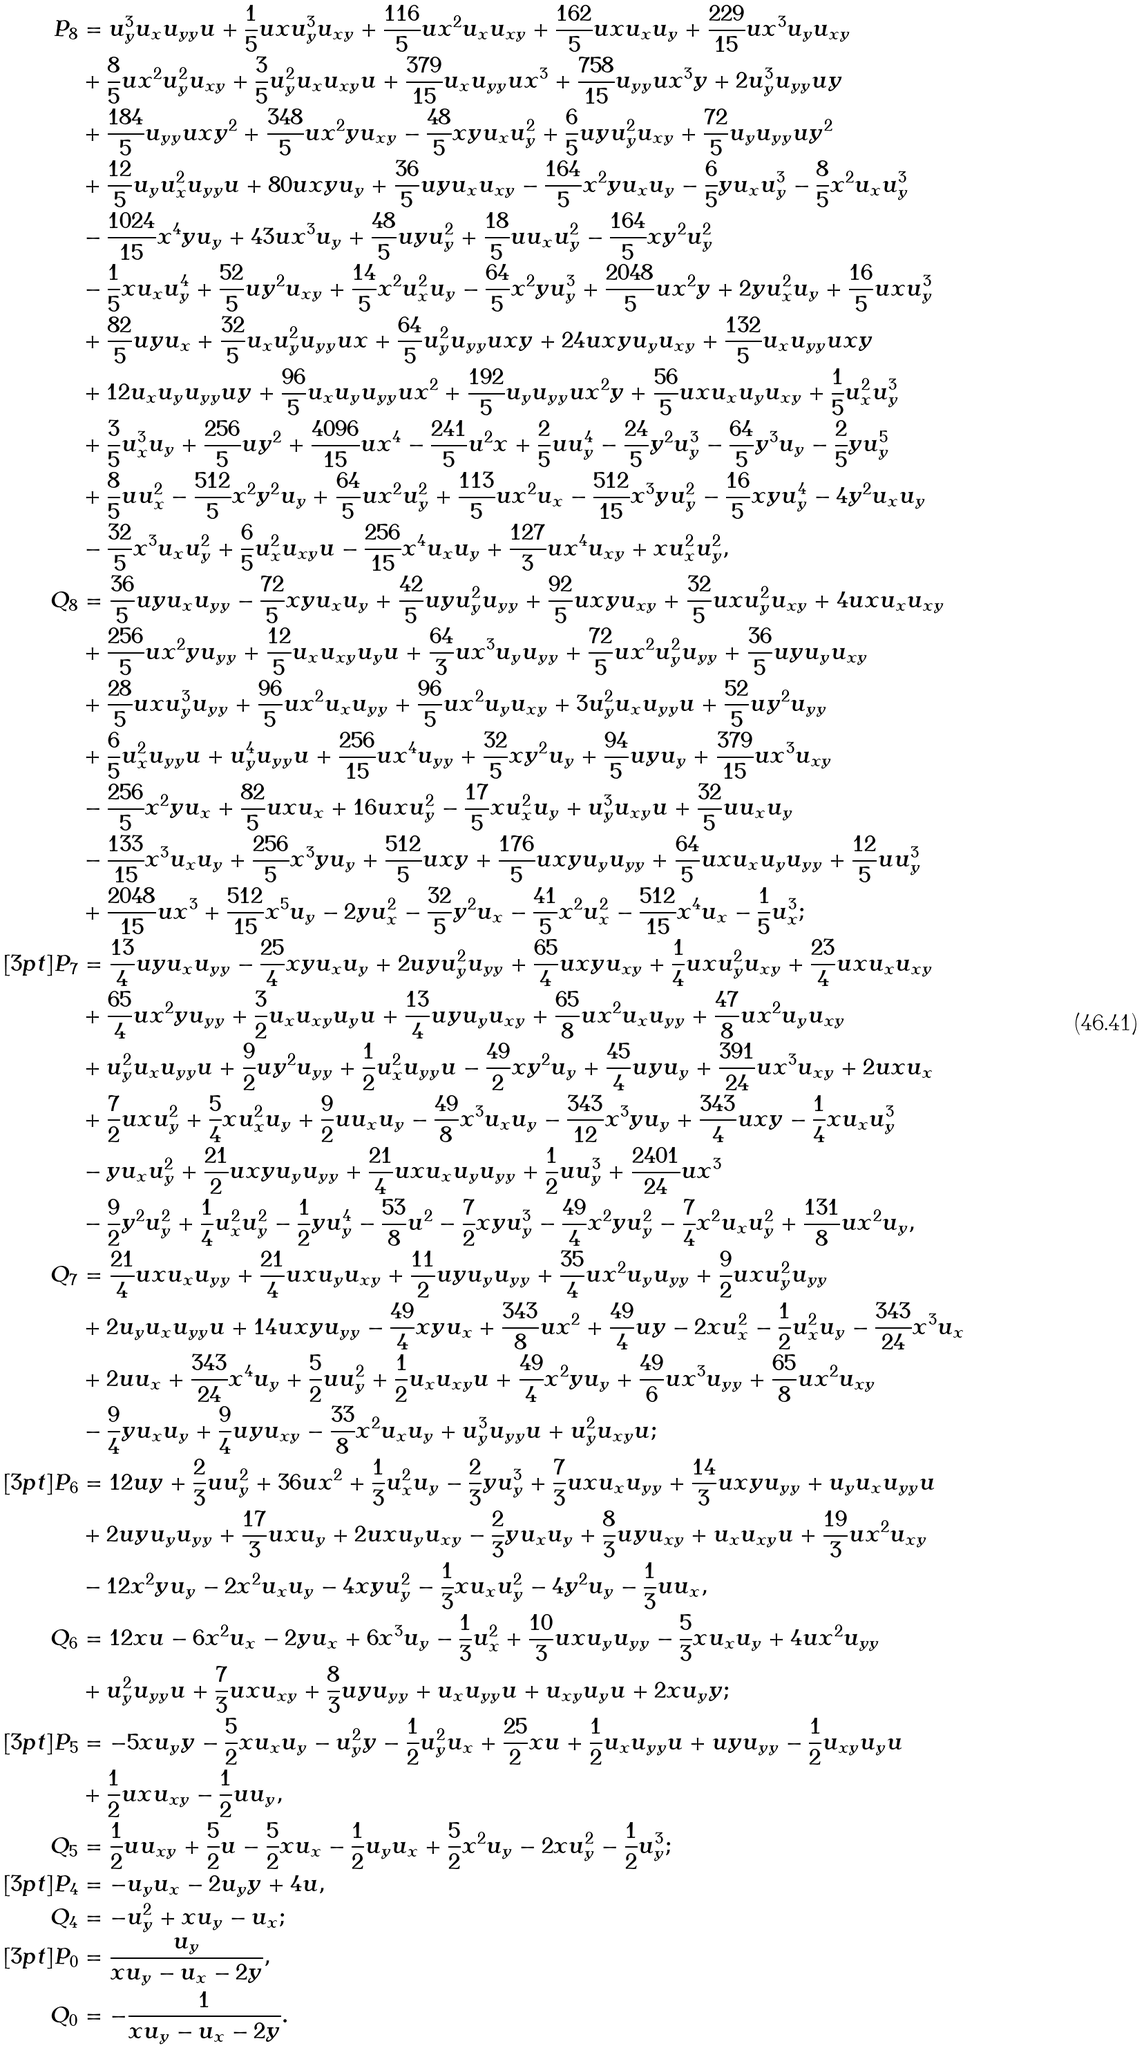<formula> <loc_0><loc_0><loc_500><loc_500>P _ { 8 } & = u _ { y } ^ { 3 } u _ { x } u _ { y y } u + \frac { 1 } { 5 } u x u _ { y } ^ { 3 } u _ { x y } + \frac { 1 1 6 } { 5 } u x ^ { 2 } u _ { x } u _ { x y } + \frac { 1 6 2 } { 5 } u x u _ { x } u _ { y } + \frac { 2 2 9 } { 1 5 } u x ^ { 3 } u _ { y } u _ { x y } \\ & + \frac { 8 } { 5 } u x ^ { 2 } u _ { y } ^ { 2 } u _ { x y } + \frac { 3 } { 5 } u _ { y } ^ { 2 } u _ { x } u _ { x y } u + \frac { 3 7 9 } { 1 5 } u _ { x } u _ { y y } u x ^ { 3 } + \frac { 7 5 8 } { 1 5 } u _ { y y } u x ^ { 3 } y + 2 u _ { y } ^ { 3 } u _ { y y } u y \\ & + \frac { 1 8 4 } { 5 } u _ { y y } u x y ^ { 2 } + \frac { 3 4 8 } { 5 } u x ^ { 2 } y u _ { x y } - \frac { 4 8 } { 5 } x y u _ { x } u _ { y } ^ { 2 } + \frac { 6 } { 5 } u y u _ { y } ^ { 2 } u _ { x y } + \frac { 7 2 } { 5 } u _ { y } u _ { y y } u y ^ { 2 } \\ & + \frac { 1 2 } { 5 } u _ { y } u _ { x } ^ { 2 } u _ { y y } u + 8 0 u x y u _ { y } + \frac { 3 6 } { 5 } u y u _ { x } u _ { x y } - \frac { 1 6 4 } { 5 } x ^ { 2 } y u _ { x } u _ { y } - \frac { 6 } { 5 } y u _ { x } u _ { y } ^ { 3 } - \frac { 8 } { 5 } x ^ { 2 } u _ { x } u _ { y } ^ { 3 } \\ & - \frac { 1 0 2 4 } { 1 5 } x ^ { 4 } y u _ { y } + 4 3 u x ^ { 3 } u _ { y } + \frac { 4 8 } { 5 } u y u _ { y } ^ { 2 } + \frac { 1 8 } { 5 } u u _ { x } u _ { y } ^ { 2 } - \frac { 1 6 4 } { 5 } x y ^ { 2 } u _ { y } ^ { 2 } \\ & - \frac { 1 } { 5 } x u _ { x } u _ { y } ^ { 4 } + \frac { 5 2 } { 5 } u y ^ { 2 } u _ { x y } + \frac { 1 4 } { 5 } x ^ { 2 } u _ { x } ^ { 2 } u _ { y } - \frac { 6 4 } { 5 } x ^ { 2 } y u _ { y } ^ { 3 } + \frac { 2 0 4 8 } { 5 } u x ^ { 2 } y + 2 y u _ { x } ^ { 2 } u _ { y } + \frac { 1 6 } { 5 } u x u _ { y } ^ { 3 } \\ & + \frac { 8 2 } { 5 } u y u _ { x } + \frac { 3 2 } { 5 } u _ { x } u _ { y } ^ { 2 } u _ { y y } u x + \frac { 6 4 } { 5 } u _ { y } ^ { 2 } u _ { y y } u x y + 2 4 u x y u _ { y } u _ { x y } + \frac { 1 3 2 } { 5 } u _ { x } u _ { y y } u x y \\ & + 1 2 u _ { x } u _ { y } u _ { y y } u y + \frac { 9 6 } { 5 } u _ { x } u _ { y } u _ { y y } u x ^ { 2 } + \frac { 1 9 2 } { 5 } u _ { y } u _ { y y } u x ^ { 2 } y + \frac { 5 6 } { 5 } u x u _ { x } u _ { y } u _ { x y } + \frac { 1 } { 5 } u _ { x } ^ { 2 } u _ { y } ^ { 3 } \\ & + \frac { 3 } { 5 } u _ { x } ^ { 3 } u _ { y } + \frac { 2 5 6 } { 5 } u y ^ { 2 } + \frac { 4 0 9 6 } { 1 5 } u x ^ { 4 } - \frac { 2 4 1 } { 5 } u ^ { 2 } x + \frac { 2 } { 5 } u u _ { y } ^ { 4 } - \frac { 2 4 } { 5 } y ^ { 2 } u _ { y } ^ { 3 } - \frac { 6 4 } { 5 } y ^ { 3 } u _ { y } - \frac { 2 } { 5 } y u _ { y } ^ { 5 } \\ & + \frac { 8 } { 5 } u u _ { x } ^ { 2 } - \frac { 5 1 2 } { 5 } x ^ { 2 } y ^ { 2 } u _ { y } + \frac { 6 4 } { 5 } u x ^ { 2 } u _ { y } ^ { 2 } + \frac { 1 1 3 } { 5 } u x ^ { 2 } u _ { x } - \frac { 5 1 2 } { 1 5 } x ^ { 3 } y u _ { y } ^ { 2 } - \frac { 1 6 } { 5 } x y u _ { y } ^ { 4 } - 4 y ^ { 2 } u _ { x } u _ { y } \\ & - \frac { 3 2 } { 5 } x ^ { 3 } u _ { x } u _ { y } ^ { 2 } + \frac { 6 } { 5 } u _ { x } ^ { 2 } u _ { x y } u - \frac { 2 5 6 } { 1 5 } x ^ { 4 } u _ { x } u _ { y } + \frac { 1 2 7 } { 3 } u x ^ { 4 } u _ { x y } + x u _ { x } ^ { 2 } u _ { y } ^ { 2 } , \\ Q _ { 8 } & = \frac { 3 6 } { 5 } u y u _ { x } u _ { y y } - \frac { 7 2 } { 5 } x y u _ { x } u _ { y } + \frac { 4 2 } { 5 } u y u _ { y } ^ { 2 } u _ { y y } + \frac { 9 2 } { 5 } u x y u _ { x y } + \frac { 3 2 } { 5 } u x u _ { y } ^ { 2 } u _ { x y } + 4 u x u _ { x } u _ { x y } \\ & + \frac { 2 5 6 } { 5 } u x ^ { 2 } y u _ { y y } + \frac { 1 2 } { 5 } u _ { x } u _ { x y } u _ { y } u + \frac { 6 4 } { 3 } u x ^ { 3 } u _ { y } u _ { y y } + \frac { 7 2 } { 5 } u x ^ { 2 } u _ { y } ^ { 2 } u _ { y y } + \frac { 3 6 } { 5 } u y u _ { y } u _ { x y } \\ & + \frac { 2 8 } { 5 } u x u _ { y } ^ { 3 } u _ { y y } + \frac { 9 6 } { 5 } u x ^ { 2 } u _ { x } u _ { y y } + \frac { 9 6 } { 5 } u x ^ { 2 } u _ { y } u _ { x y } + 3 u _ { y } ^ { 2 } u _ { x } u _ { y y } u + \frac { 5 2 } { 5 } u y ^ { 2 } u _ { y y } \\ & + \frac { 6 } { 5 } u _ { x } ^ { 2 } u _ { y y } u + u _ { y } ^ { 4 } u _ { y y } u + \frac { 2 5 6 } { 1 5 } u x ^ { 4 } u _ { y y } + \frac { 3 2 } { 5 } x y ^ { 2 } u _ { y } + \frac { 9 4 } { 5 } u y u _ { y } + \frac { 3 7 9 } { 1 5 } u x ^ { 3 } u _ { x y } \\ & - \frac { 2 5 6 } { 5 } x ^ { 2 } y u _ { x } + \frac { 8 2 } { 5 } u x u _ { x } + 1 6 u x u _ { y } ^ { 2 } - \frac { 1 7 } { 5 } x u _ { x } ^ { 2 } u _ { y } + u _ { y } ^ { 3 } u _ { x y } u + \frac { 3 2 } { 5 } u u _ { x } u _ { y } \\ & - \frac { 1 3 3 } { 1 5 } x ^ { 3 } u _ { x } u _ { y } + \frac { 2 5 6 } { 5 } x ^ { 3 } y u _ { y } + \frac { 5 1 2 } { 5 } u x y + \frac { 1 7 6 } { 5 } u x y u _ { y } u _ { y y } + \frac { 6 4 } { 5 } u x u _ { x } u _ { y } u _ { y y } + \frac { 1 2 } { 5 } u u _ { y } ^ { 3 } \\ & + \frac { 2 0 4 8 } { 1 5 } u x ^ { 3 } + \frac { 5 1 2 } { 1 5 } x ^ { 5 } u _ { y } - 2 y u _ { x } ^ { 2 } - \frac { 3 2 } { 5 } y ^ { 2 } u _ { x } - \frac { 4 1 } { 5 } x ^ { 2 } u _ { x } ^ { 2 } - \frac { 5 1 2 } { 1 5 } x ^ { 4 } u _ { x } - \frac { 1 } { 5 } u _ { x } ^ { 3 } ; \\ [ 3 p t ] P _ { 7 } & = \frac { 1 3 } { 4 } u y u _ { x } u _ { y y } - \frac { 2 5 } { 4 } x y u _ { x } u _ { y } + 2 u y u _ { y } ^ { 2 } u _ { y y } + \frac { 6 5 } { 4 } u x y u _ { x y } + \frac { 1 } { 4 } u x u _ { y } ^ { 2 } u _ { x y } + \frac { 2 3 } { 4 } u x u _ { x } u _ { x y } \\ & + \frac { 6 5 } { 4 } u x ^ { 2 } y u _ { y y } + \frac { 3 } { 2 } u _ { x } u _ { x y } u _ { y } u + \frac { 1 3 } { 4 } u y u _ { y } u _ { x y } + \frac { 6 5 } { 8 } u x ^ { 2 } u _ { x } u _ { y y } + \frac { 4 7 } { 8 } u x ^ { 2 } u _ { y } u _ { x y } \\ & + u _ { y } ^ { 2 } u _ { x } u _ { y y } u + \frac { 9 } { 2 } u y ^ { 2 } u _ { y y } + \frac { 1 } { 2 } u _ { x } ^ { 2 } u _ { y y } u - \frac { 4 9 } { 2 } x y ^ { 2 } u _ { y } + \frac { 4 5 } { 4 } u y u _ { y } + \frac { 3 9 1 } { 2 4 } u x ^ { 3 } u _ { x y } + 2 u x u _ { x } \\ & + \frac { 7 } { 2 } u x u _ { y } ^ { 2 } + \frac { 5 } { 4 } x u _ { x } ^ { 2 } u _ { y } + \frac { 9 } { 2 } u u _ { x } u _ { y } - \frac { 4 9 } { 8 } x ^ { 3 } u _ { x } u _ { y } - \frac { 3 4 3 } { 1 2 } x ^ { 3 } y u _ { y } + \frac { 3 4 3 } { 4 } u x y - \frac { 1 } { 4 } x u _ { x } u _ { y } ^ { 3 } \\ & - y u _ { x } u _ { y } ^ { 2 } + \frac { 2 1 } { 2 } u x y u _ { y } u _ { y y } + \frac { 2 1 } { 4 } u x u _ { x } u _ { y } u _ { y y } + \frac { 1 } { 2 } u u _ { y } ^ { 3 } + \frac { 2 4 0 1 } { 2 4 } u x ^ { 3 } \\ & - \frac { 9 } { 2 } y ^ { 2 } u _ { y } ^ { 2 } + \frac { 1 } { 4 } u _ { x } ^ { 2 } u _ { y } ^ { 2 } - \frac { 1 } { 2 } y u _ { y } ^ { 4 } - \frac { 5 3 } { 8 } u ^ { 2 } - \frac { 7 } { 2 } x y u _ { y } ^ { 3 } - \frac { 4 9 } { 4 } x ^ { 2 } y u _ { y } ^ { 2 } - \frac { 7 } { 4 } x ^ { 2 } u _ { x } u _ { y } ^ { 2 } + \frac { 1 3 1 } { 8 } u x ^ { 2 } u _ { y } , \\ Q _ { 7 } & = \frac { 2 1 } { 4 } u x u _ { x } u _ { y y } + \frac { 2 1 } { 4 } u x u _ { y } u _ { x y } + \frac { 1 1 } { 2 } u y u _ { y } u _ { y y } + \frac { 3 5 } { 4 } u x ^ { 2 } u _ { y } u _ { y y } + \frac { 9 } { 2 } u x u _ { y } ^ { 2 } u _ { y y } \\ & + 2 u _ { y } u _ { x } u _ { y y } u + 1 4 u x y u _ { y y } - \frac { 4 9 } { 4 } x y u _ { x } + \frac { 3 4 3 } { 8 } u x ^ { 2 } + \frac { 4 9 } { 4 } u y - 2 x u _ { x } ^ { 2 } - \frac { 1 } { 2 } u _ { x } ^ { 2 } u _ { y } - \frac { 3 4 3 } { 2 4 } x ^ { 3 } u _ { x } \\ & + 2 u u _ { x } + \frac { 3 4 3 } { 2 4 } x ^ { 4 } u _ { y } + \frac { 5 } { 2 } u u _ { y } ^ { 2 } + \frac { 1 } { 2 } u _ { x } u _ { x y } u + \frac { 4 9 } { 4 } x ^ { 2 } y u _ { y } + \frac { 4 9 } { 6 } u x ^ { 3 } u _ { y y } + \frac { 6 5 } { 8 } u x ^ { 2 } u _ { x y } \\ & - \frac { 9 } { 4 } y u _ { x } u _ { y } + \frac { 9 } { 4 } u y u _ { x y } - \frac { 3 3 } { 8 } x ^ { 2 } u _ { x } u _ { y } + u _ { y } ^ { 3 } u _ { y y } u + u _ { y } ^ { 2 } u _ { x y } u ; \\ [ 3 p t ] P _ { 6 } & = 1 2 u y + \frac { 2 } { 3 } u u _ { y } ^ { 2 } + 3 6 u x ^ { 2 } + \frac { 1 } { 3 } u _ { x } ^ { 2 } u _ { y } - \frac { 2 } { 3 } y u _ { y } ^ { 3 } + \frac { 7 } { 3 } u x u _ { x } u _ { y y } + \frac { 1 4 } { 3 } u x y u _ { y y } + u _ { y } u _ { x } u _ { y y } u \\ & + 2 u y u _ { y } u _ { y y } + \frac { 1 7 } { 3 } u x u _ { y } + 2 u x u _ { y } u _ { x y } - \frac { 2 } { 3 } y u _ { x } u _ { y } + \frac { 8 } { 3 } u y u _ { x y } + u _ { x } u _ { x y } u + \frac { 1 9 } { 3 } u x ^ { 2 } u _ { x y } \\ & - 1 2 x ^ { 2 } y u _ { y } - 2 x ^ { 2 } u _ { x } u _ { y } - 4 x y u _ { y } ^ { 2 } - \frac { 1 } { 3 } x u _ { x } u _ { y } ^ { 2 } - 4 y ^ { 2 } u _ { y } - \frac { 1 } { 3 } u u _ { x } , \\ Q _ { 6 } & = 1 2 x u - 6 x ^ { 2 } u _ { x } - 2 y u _ { x } + 6 x ^ { 3 } u _ { y } - \frac { 1 } { 3 } u _ { x } ^ { 2 } + \frac { 1 0 } { 3 } u x u _ { y } u _ { y y } - \frac { 5 } { 3 } x u _ { x } u _ { y } + 4 u x ^ { 2 } u _ { y y } \\ & + u _ { y } ^ { 2 } u _ { y y } u + \frac { 7 } { 3 } u x u _ { x y } + \frac { 8 } { 3 } u y u _ { y y } + u _ { x } u _ { y y } u + u _ { x y } u _ { y } u + 2 x u _ { y } y ; \\ [ 3 p t ] P _ { 5 } & = - 5 x u _ { y } y - \frac { 5 } { 2 } x u _ { x } u _ { y } - u _ { y } ^ { 2 } y - \frac { 1 } { 2 } u _ { y } ^ { 2 } u _ { x } + \frac { 2 5 } { 2 } x u + \frac { 1 } { 2 } u _ { x } u _ { y y } u + u y u _ { y y } - \frac { 1 } { 2 } u _ { x y } u _ { y } u \\ & + \frac { 1 } { 2 } u x u _ { x y } - \frac { 1 } { 2 } u u _ { y } , \\ Q _ { 5 } & = \frac { 1 } { 2 } u u _ { x y } + \frac { 5 } { 2 } u - \frac { 5 } { 2 } x u _ { x } - \frac { 1 } { 2 } u _ { y } u _ { x } + \frac { 5 } { 2 } x ^ { 2 } u _ { y } - 2 x u _ { y } ^ { 2 } - \frac { 1 } { 2 } u _ { y } ^ { 3 } ; \\ [ 3 p t ] P _ { 4 } & = - u _ { y } u _ { x } - 2 u _ { y } y + 4 u , \\ Q _ { 4 } & = - u _ { y } ^ { 2 } + x u _ { y } - u _ { x } ; \\ [ 3 p t ] P _ { 0 } & = \frac { u _ { y } } { x u _ { y } - u _ { x } - 2 y } , \\ Q _ { 0 } & = - \frac { 1 } { x u _ { y } - u _ { x } - 2 y } .</formula> 